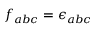Convert formula to latex. <formula><loc_0><loc_0><loc_500><loc_500>f _ { a b c } = \epsilon _ { a b c }</formula> 